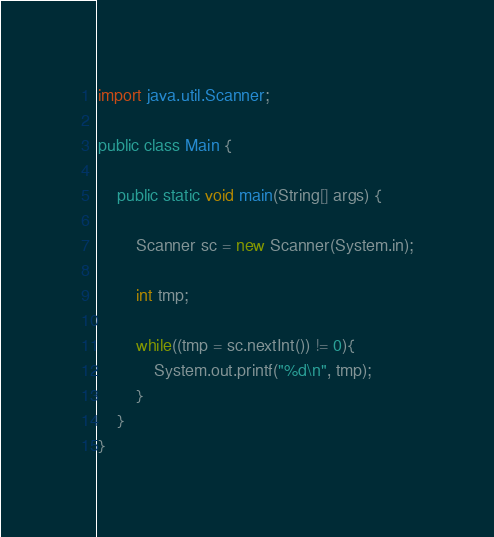Convert code to text. <code><loc_0><loc_0><loc_500><loc_500><_Java_>import java.util.Scanner;

public class Main {

	public static void main(String[] args) {

		Scanner sc = new Scanner(System.in);

		int tmp;

		while((tmp = sc.nextInt()) != 0){
			System.out.printf("%d\n", tmp);
		}
	}
}


</code> 